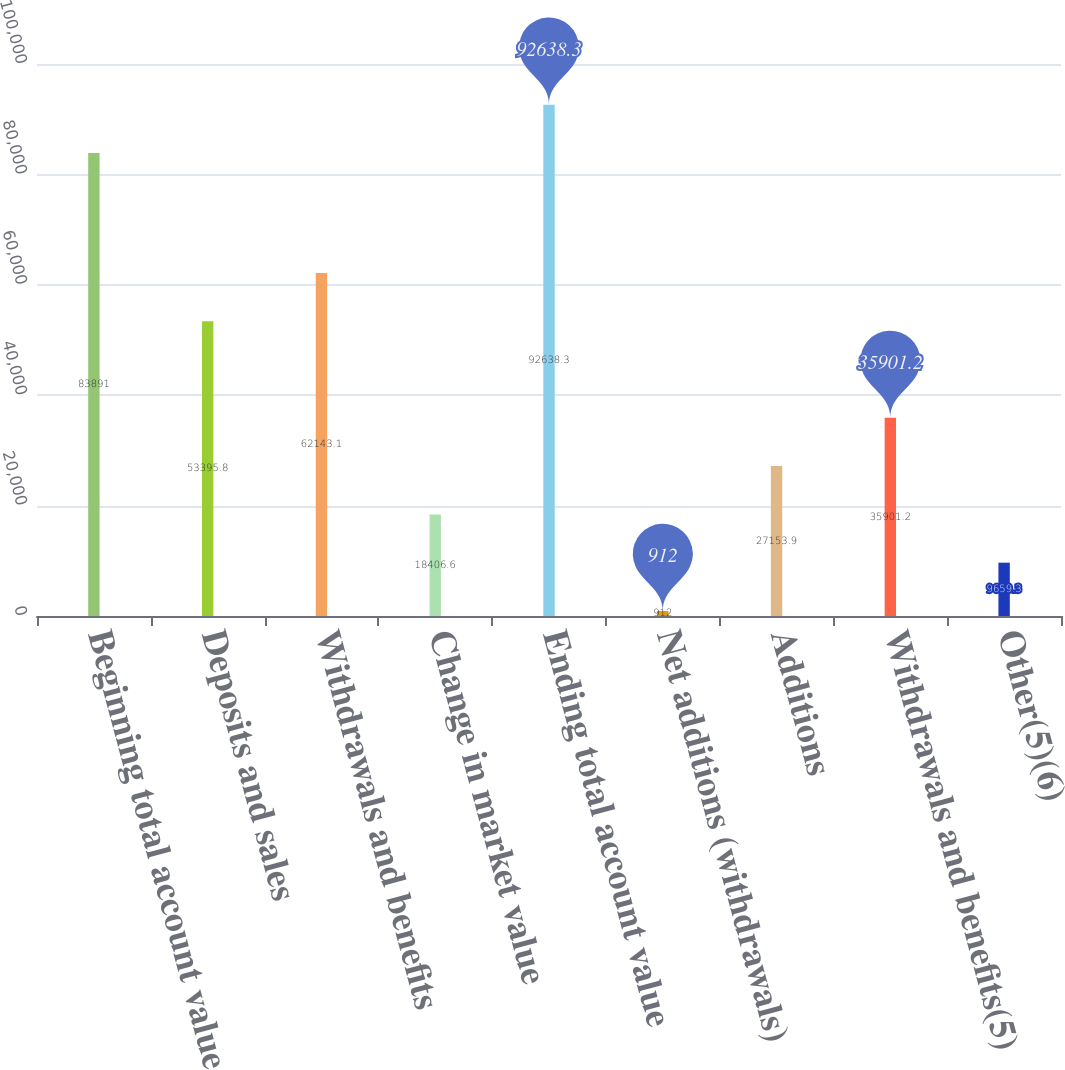Convert chart. <chart><loc_0><loc_0><loc_500><loc_500><bar_chart><fcel>Beginning total account value<fcel>Deposits and sales<fcel>Withdrawals and benefits<fcel>Change in market value<fcel>Ending total account value<fcel>Net additions (withdrawals)<fcel>Additions<fcel>Withdrawals and benefits(5)<fcel>Other(5)(6)<nl><fcel>83891<fcel>53395.8<fcel>62143.1<fcel>18406.6<fcel>92638.3<fcel>912<fcel>27153.9<fcel>35901.2<fcel>9659.3<nl></chart> 